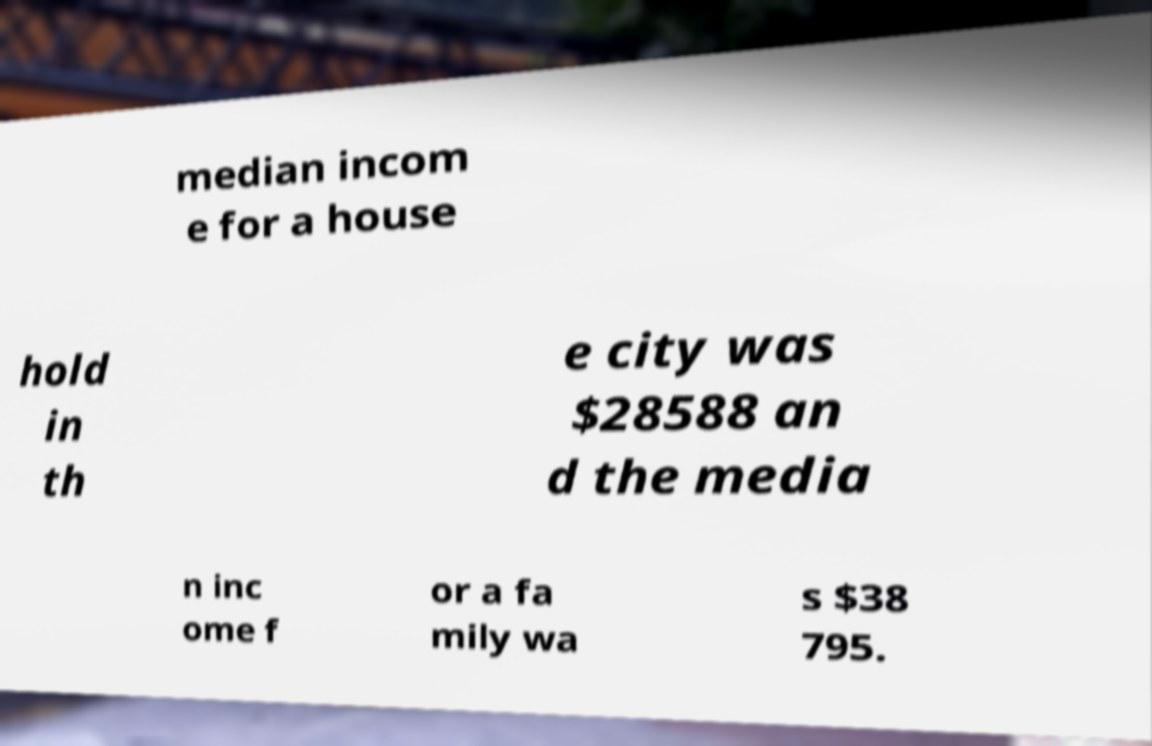There's text embedded in this image that I need extracted. Can you transcribe it verbatim? median incom e for a house hold in th e city was $28588 an d the media n inc ome f or a fa mily wa s $38 795. 